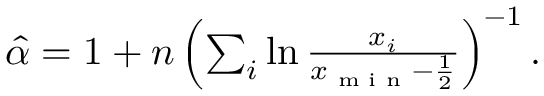<formula> <loc_0><loc_0><loc_500><loc_500>\begin{array} { r } { \hat { \alpha } = 1 + n \left ( \sum _ { i } \ln \frac { x _ { i } } { x _ { \min } - \frac { 1 } { 2 } } \right ) ^ { - 1 } . } \end{array}</formula> 